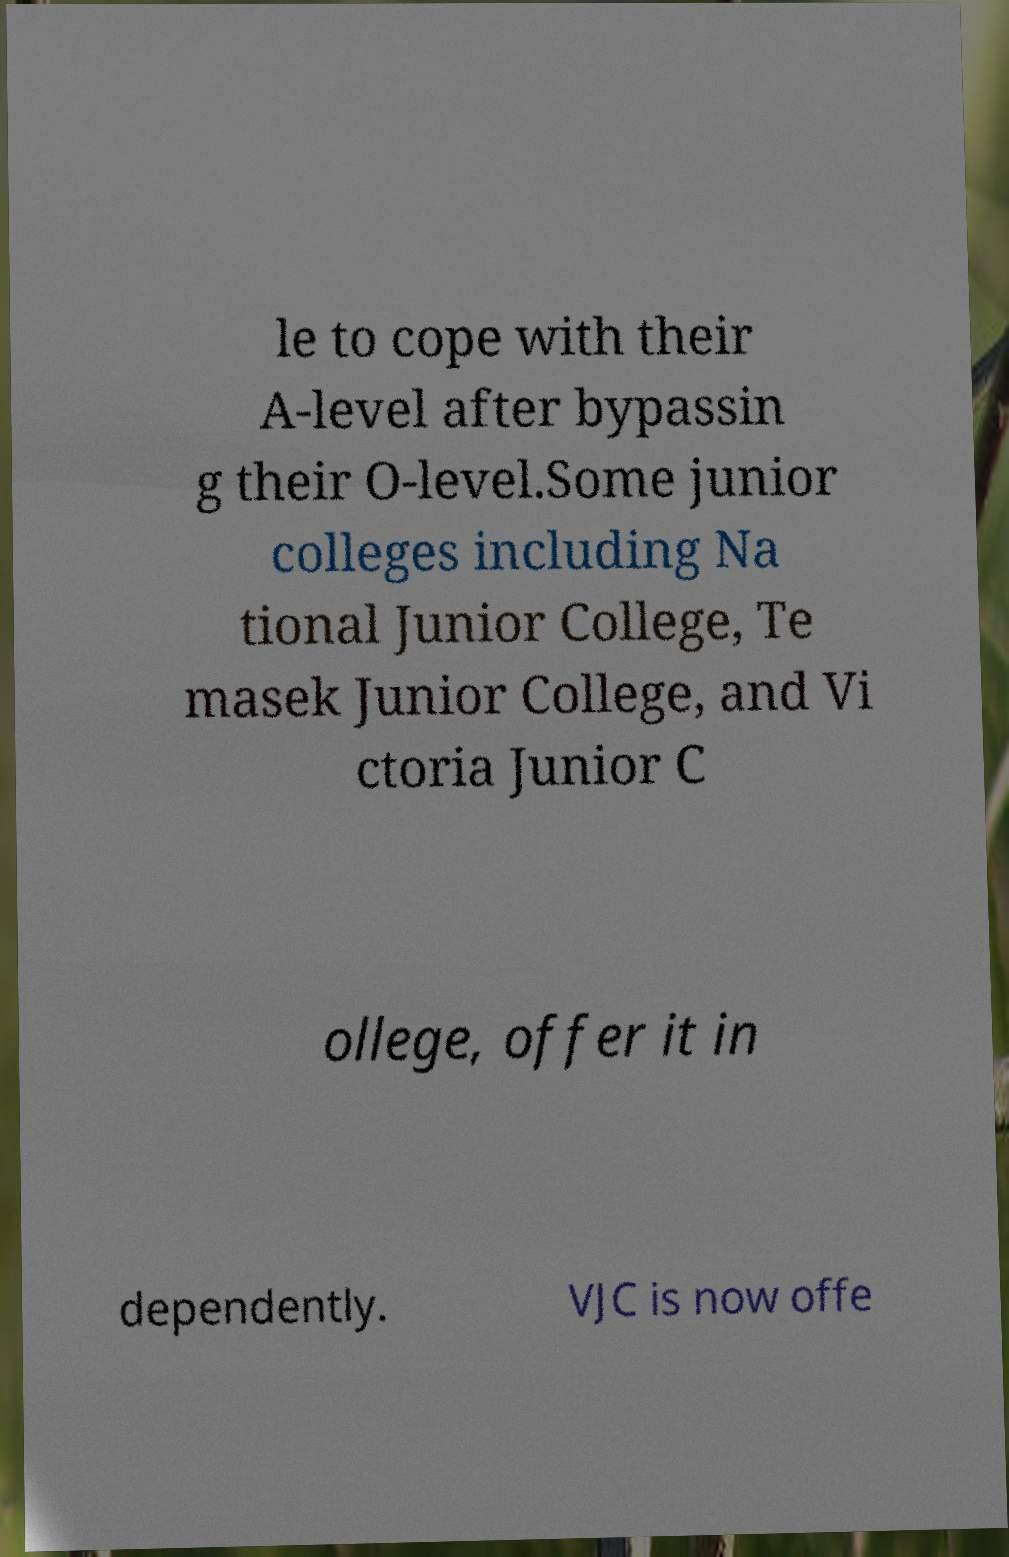Can you read and provide the text displayed in the image?This photo seems to have some interesting text. Can you extract and type it out for me? le to cope with their A-level after bypassin g their O-level.Some junior colleges including Na tional Junior College, Te masek Junior College, and Vi ctoria Junior C ollege, offer it in dependently. VJC is now offe 